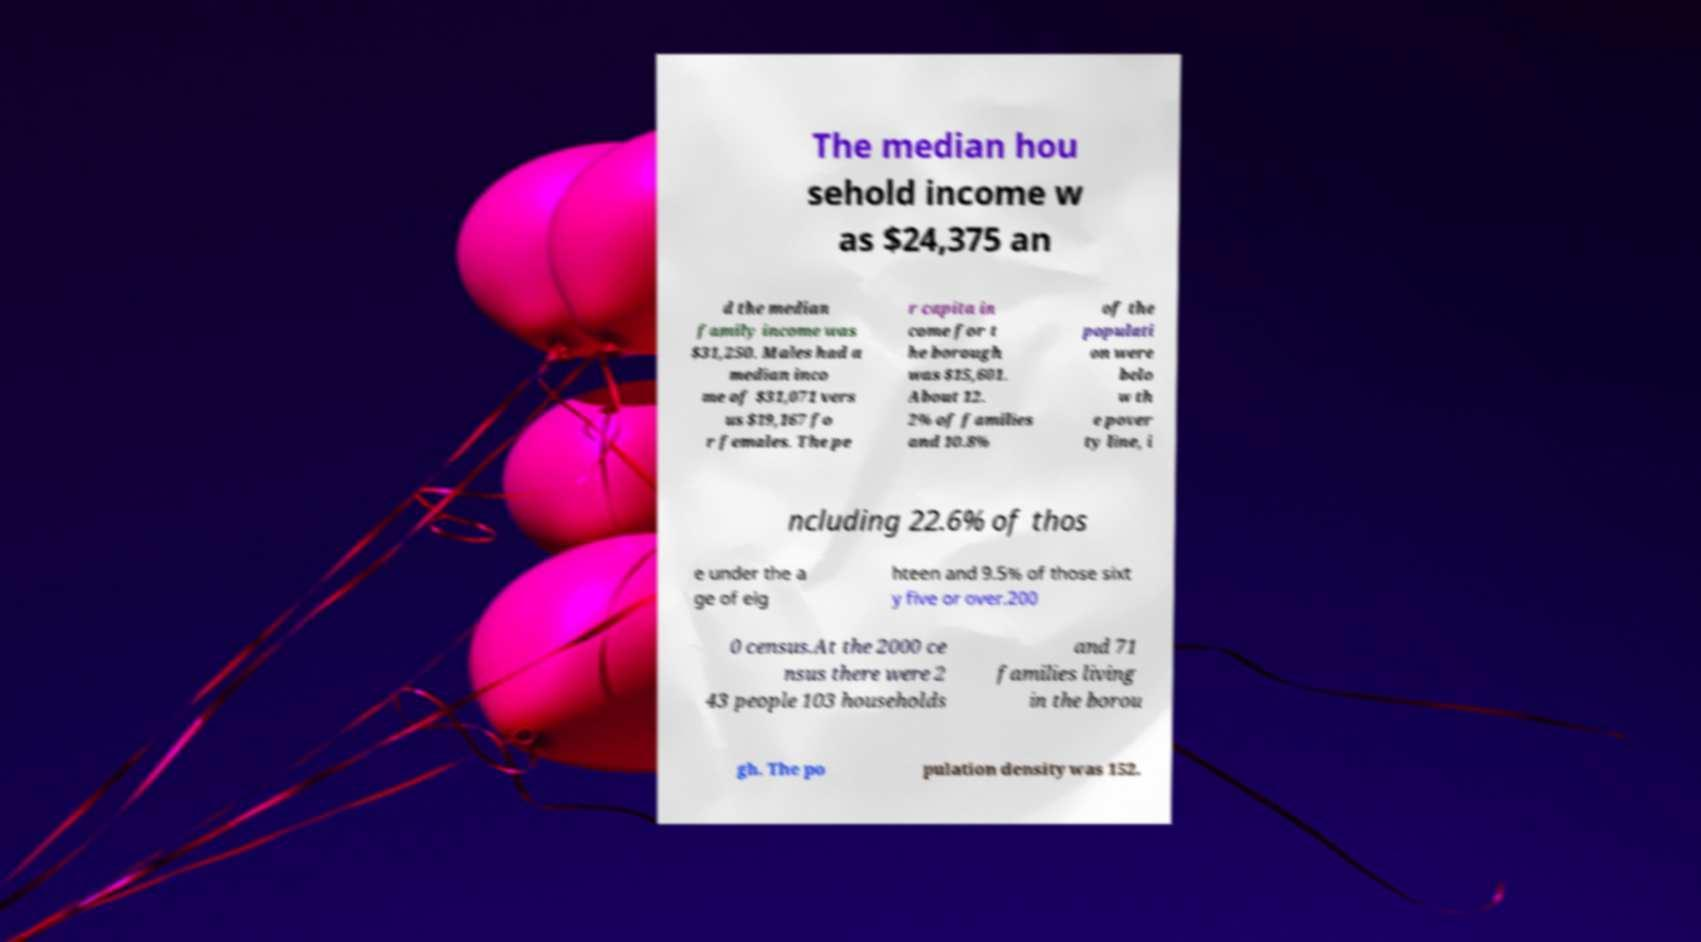Can you read and provide the text displayed in the image?This photo seems to have some interesting text. Can you extract and type it out for me? The median hou sehold income w as $24,375 an d the median family income was $31,250. Males had a median inco me of $31,071 vers us $19,167 fo r females. The pe r capita in come for t he borough was $15,601. About 12. 2% of families and 10.8% of the populati on were belo w th e pover ty line, i ncluding 22.6% of thos e under the a ge of eig hteen and 9.5% of those sixt y five or over.200 0 census.At the 2000 ce nsus there were 2 43 people 103 households and 71 families living in the borou gh. The po pulation density was 152. 